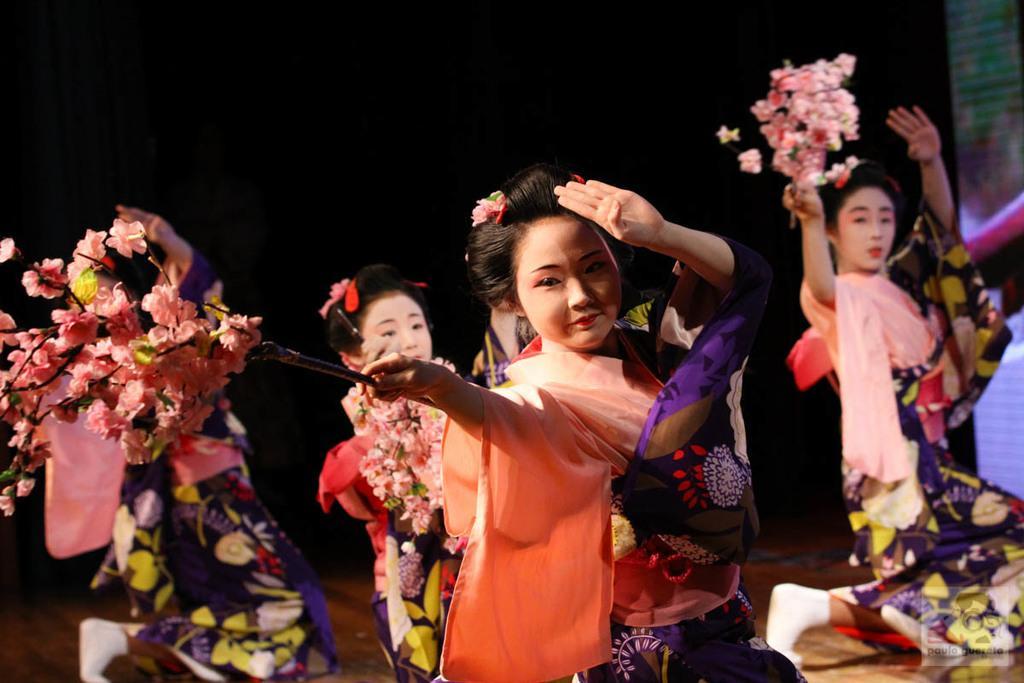How would you summarize this image in a sentence or two? In the image we can see there are many women wearing clothes. This is a flower bookey and the floor. 